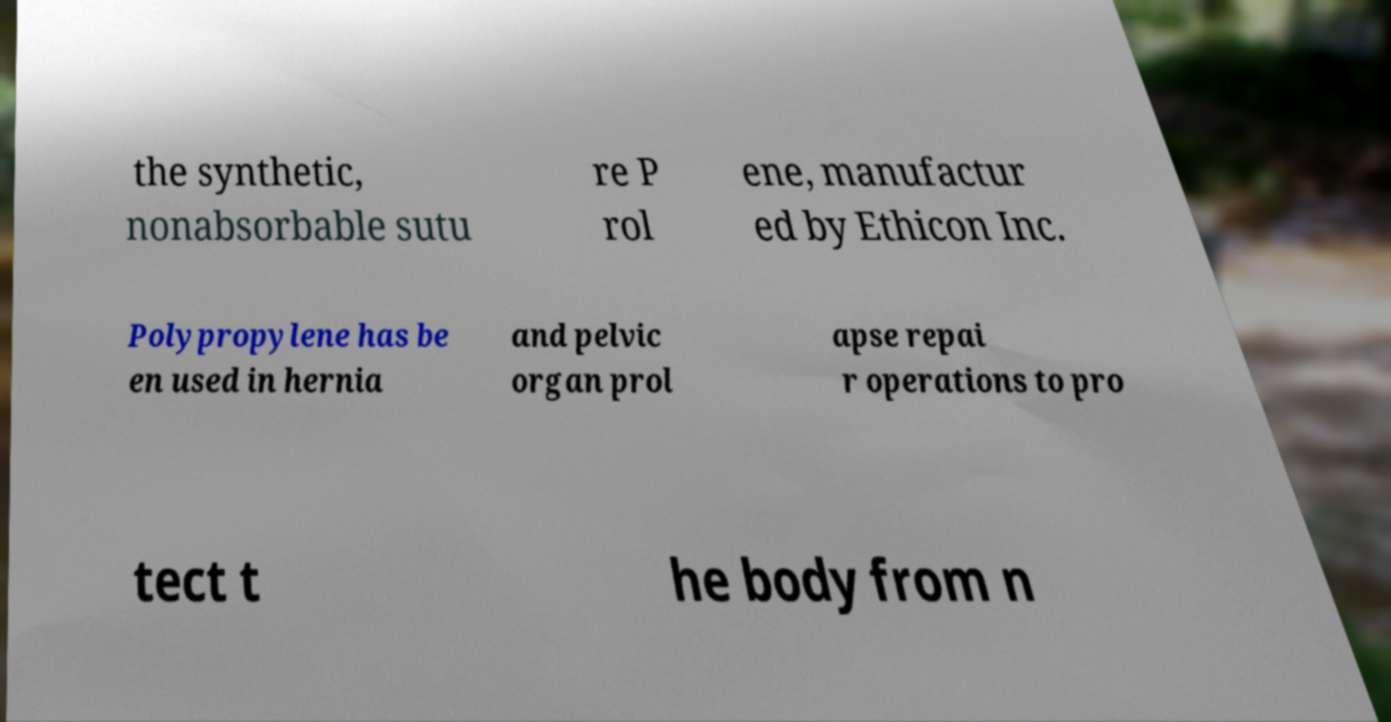Could you assist in decoding the text presented in this image and type it out clearly? the synthetic, nonabsorbable sutu re P rol ene, manufactur ed by Ethicon Inc. Polypropylene has be en used in hernia and pelvic organ prol apse repai r operations to pro tect t he body from n 